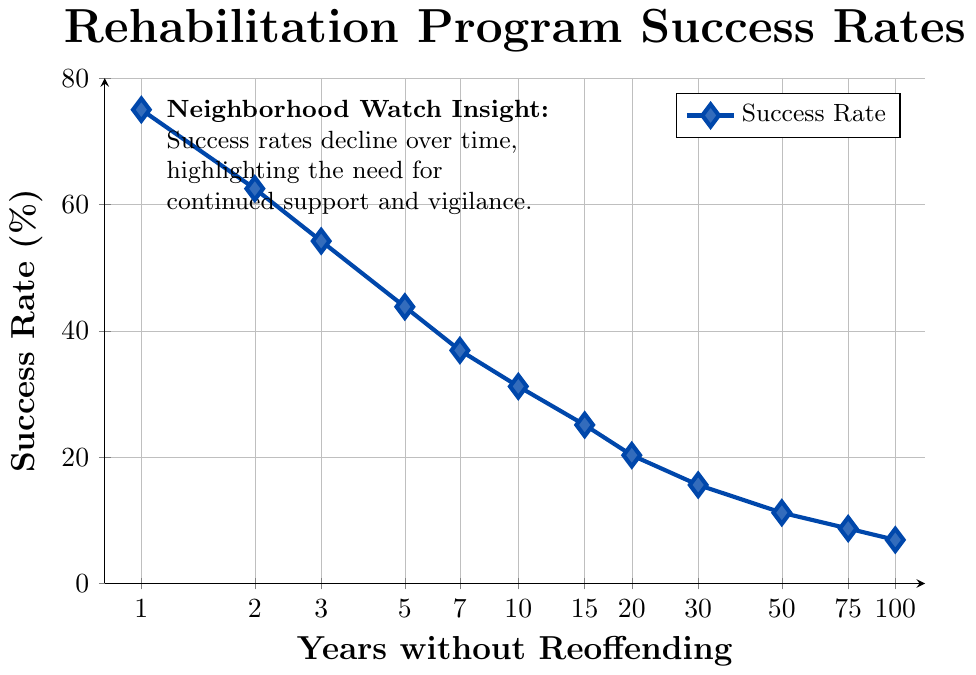What is the success rate of rehabilitation programs for parolees at the 5-year mark? From the figure, locate the data point corresponding to 5 years along the x-axis. The y-axis value at this point indicates the success rate.
Answer: 43.8% How does the success rate change from 1 year to 2 years without reoffending? Identify and compare the success rates at 1 year (75.0%) and 2 years (62.5%). Calculate the difference: 75.0% - 62.5%.
Answer: Decreases by 12.5% At what rate does the success rate of rehabilitation programs decline between 10 years and 20 years without reoffending? The success rate at 10 years is 31.2% and at 20 years is 20.3%. The difference is 31.2% - 20.3% = 10.9%. So, the decline for these 10 years is 10.9%.
Answer: Decrease by 10.9% What is the success rate difference between years 3, 7, and 30? Extract success rates for 3 (54.2%), 7 (36.9%), and 30 years (15.6%). Calculate the differences: 54.2% - 36.9% and 36.9% - 15.6%.
Answer: 17.3% and 21.3% Is there a year after which the success rate of rehabilitation programs drops below 20%? If so, when? Examine the y-values of success rates and find the first year where the rate drops below 20%. This happens between 20 years (20.3%) and 30 years (15.6%).
Answer: After 20 years What overall trend do you observe in the success rates over time? Obverse the pattern of the data points. They consistently decrease as the years increase.
Answer: Decreasing trend Which two consecutive time points have the smallest decline in success rate? Calculate the difference between all consecutive time points and identify the smallest value. Check from 3 years (54.2%) to 5 years (43.8%): 54.2% - 43.8% = 10.4%, which is the smallest decline.
Answer: Between 3 to 5 years On what intervals do the success rates appear to reduce more sharply? Visually inspect the steepness of the decline between intervals. It is sharpest initially and reduces gradually, especially between every 2-5 years.
Answer: 1 to 5 years and 20 to 50 years What is the percent change in success rate from 15 to 100 years? The success rate at 15 years is 25.1% and at 100 years is 6.9%. Percent change is calculated as [(25.1 - 6.9) / 25.1] * 100.
Answer: 72.5% decrease How does the success rate between columns 7 and 5 relate visually? Locate columns 7 and 5 on the x-axis. The success rate for 7 years is 36.9% and for 5 years is 43.8%. 7 years have a shorter height than 5 years.
Answer: 7 years is shorter than 5 years 